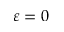Convert formula to latex. <formula><loc_0><loc_0><loc_500><loc_500>\varepsilon = 0</formula> 